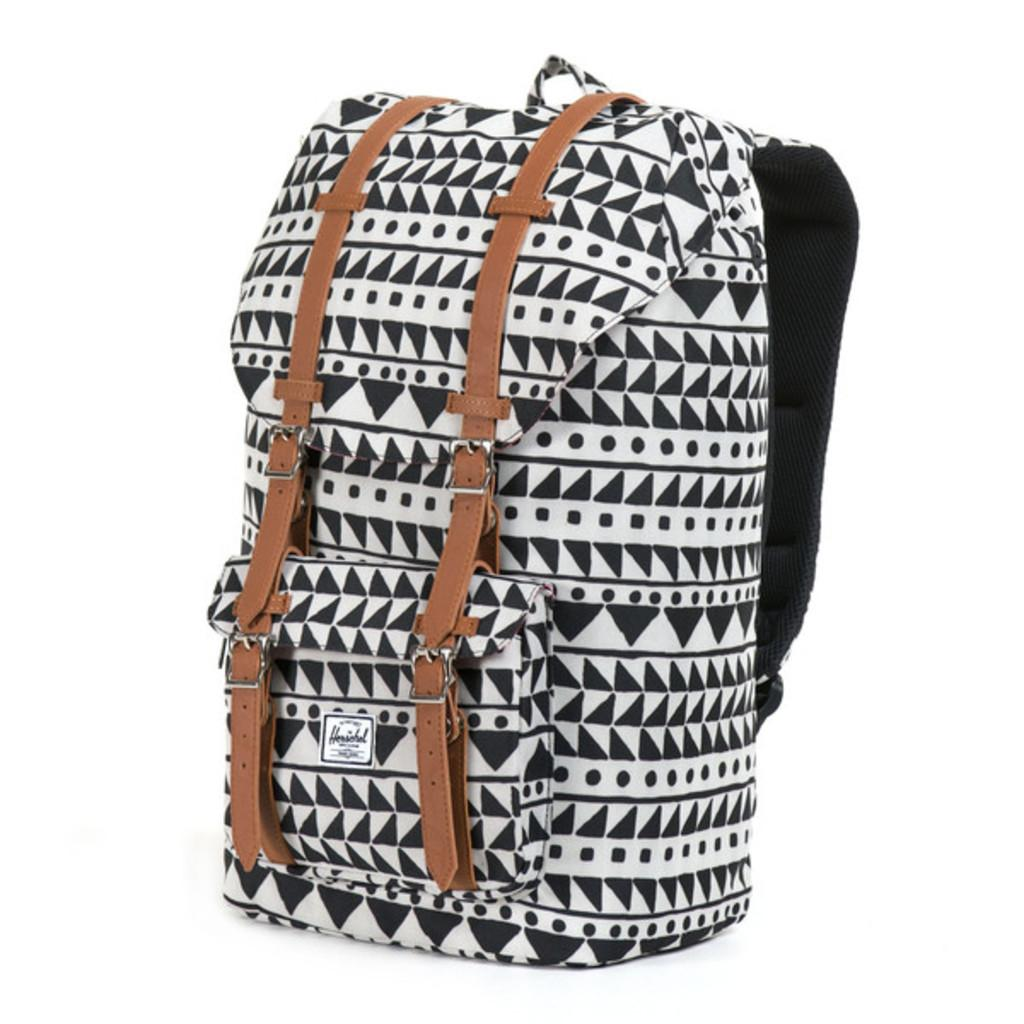What object is present in the image? There is a bag in the image. What colors are featured on the bag? The bag has a combination of black and white color, as well as brown color strips. What type of oven is used to cook the whip in the image? There is no oven or whip present in the image; it only features a bag with specific colors and patterns. 